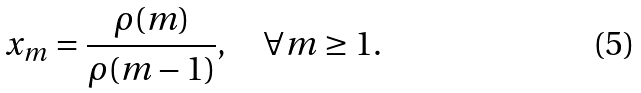<formula> <loc_0><loc_0><loc_500><loc_500>x _ { m } = \frac { \rho ( m ) } { \rho ( m - 1 ) } , \quad \forall m \geq 1 .</formula> 